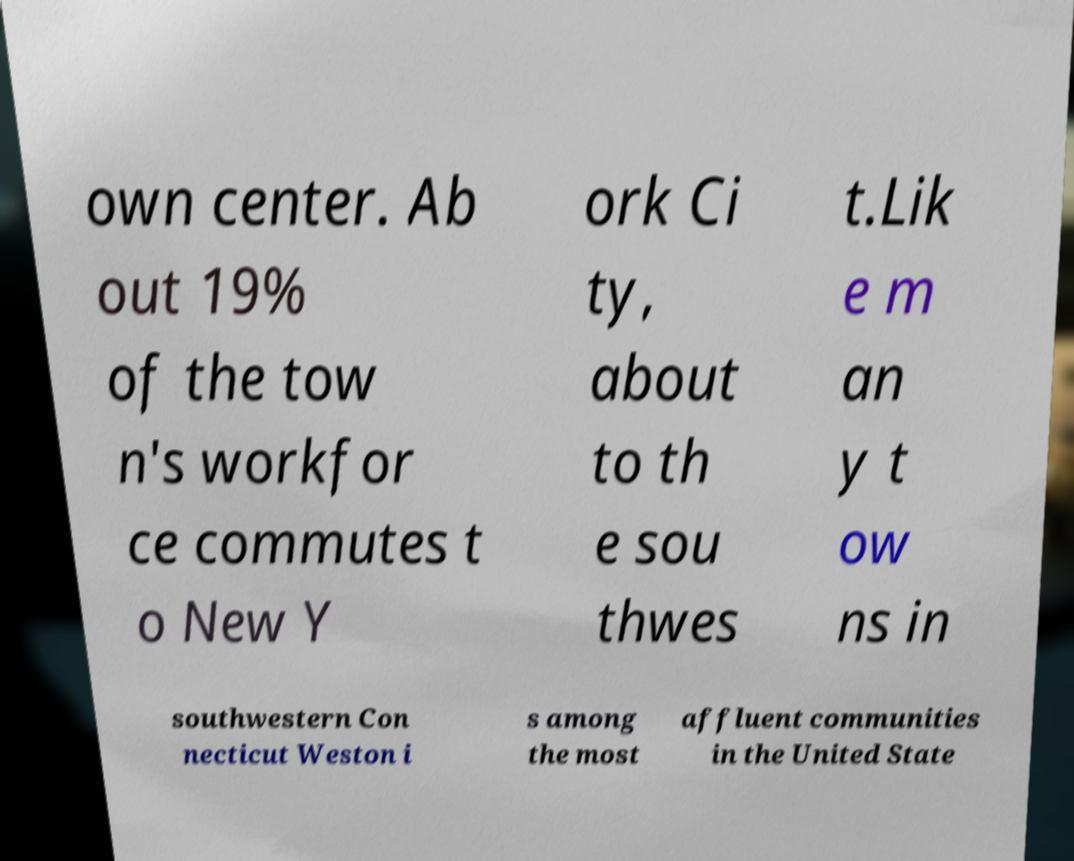Could you assist in decoding the text presented in this image and type it out clearly? own center. Ab out 19% of the tow n's workfor ce commutes t o New Y ork Ci ty, about to th e sou thwes t.Lik e m an y t ow ns in southwestern Con necticut Weston i s among the most affluent communities in the United State 